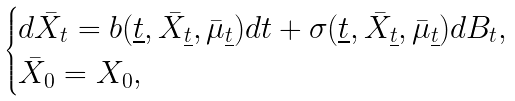<formula> <loc_0><loc_0><loc_500><loc_500>\begin{cases} d \bar { X } _ { t } = b ( \underline { t } , \bar { X } _ { \underline { t } } , \bar { \mu } _ { \underline { t } } ) d t + \sigma ( \underline { t } , \bar { X } _ { \underline { t } } , \bar { \mu } _ { \underline { t } } ) d B _ { t } , \\ \bar { X } _ { 0 } = X _ { 0 } , \end{cases}</formula> 